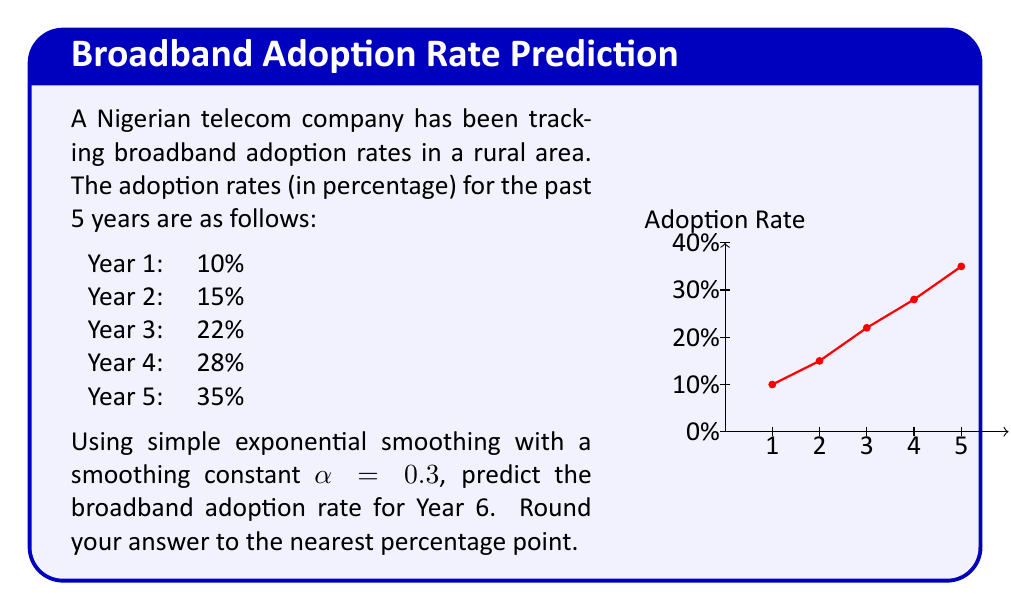Show me your answer to this math problem. To solve this problem using simple exponential smoothing, we'll follow these steps:

1) The formula for simple exponential smoothing is:
   $$F_{t+1} = \alpha Y_t + (1-\alpha)F_t$$
   where $F_{t+1}$ is the forecast for the next period, $Y_t$ is the actual value at time $t$, and $F_t$ is the forecast for the current period.

2) We're given $\alpha = 0.3$. We'll start with $F_1 = Y_1 = 10\%$ (the first actual value).

3) Let's calculate the forecasts for each year:

   For Year 2: $F_2 = 0.3(10) + 0.7(10) = 10\%$
   For Year 3: $F_3 = 0.3(15) + 0.7(10) = 11.5\%$
   For Year 4: $F_4 = 0.3(22) + 0.7(11.5) = 14.65\%$
   For Year 5: $F_5 = 0.3(28) + 0.7(14.65) = 18.655\%$

4) Now, we can forecast Year 6:
   
   $F_6 = 0.3(35) + 0.7(18.655) = 23.5585\%$

5) Rounding to the nearest percentage point gives us 24%.
Answer: 24% 